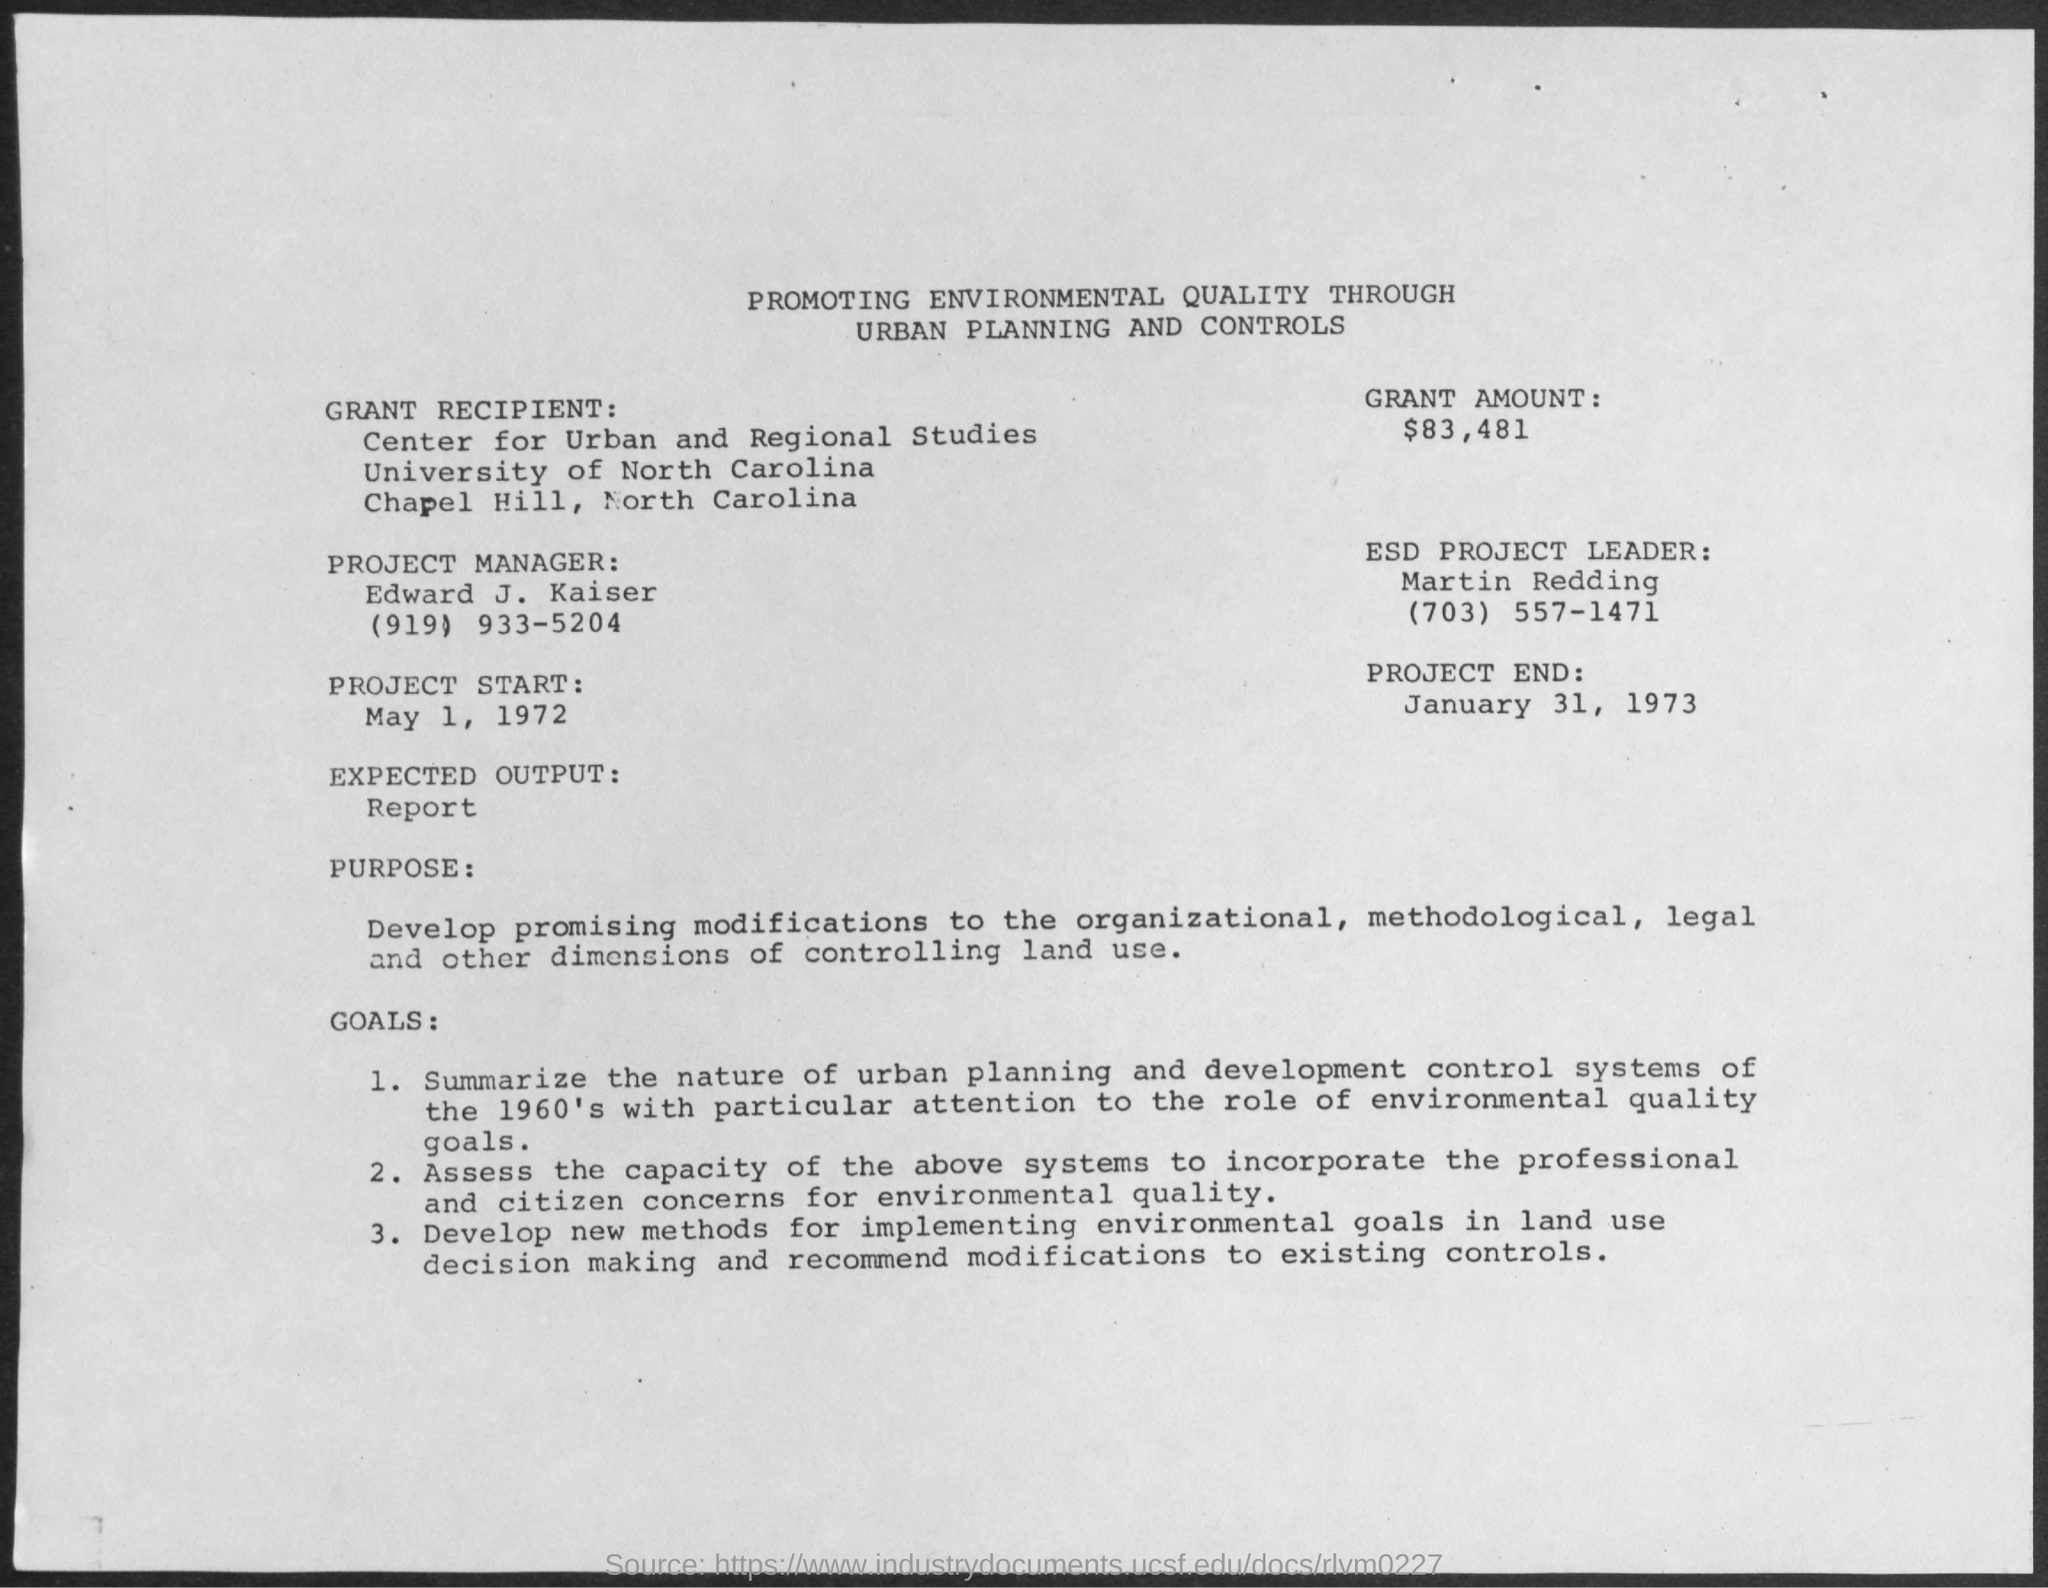What is the project start date ?
Offer a very short reply. May 1, 1972. What is the project end date ?
Your answer should be very brief. January 31, 1973. How much is the grant amount ?
Provide a succinct answer. $83,481. Who is the esd project leader ?
Provide a short and direct response. Martin Redding. Who is the project manager ?
Your answer should be compact. Edward J. Kaiser. What is the name of the university ?
Give a very brief answer. University of north carolina. What is the contact number of edward j. kaiser?
Give a very brief answer. (919) 933-5204. 